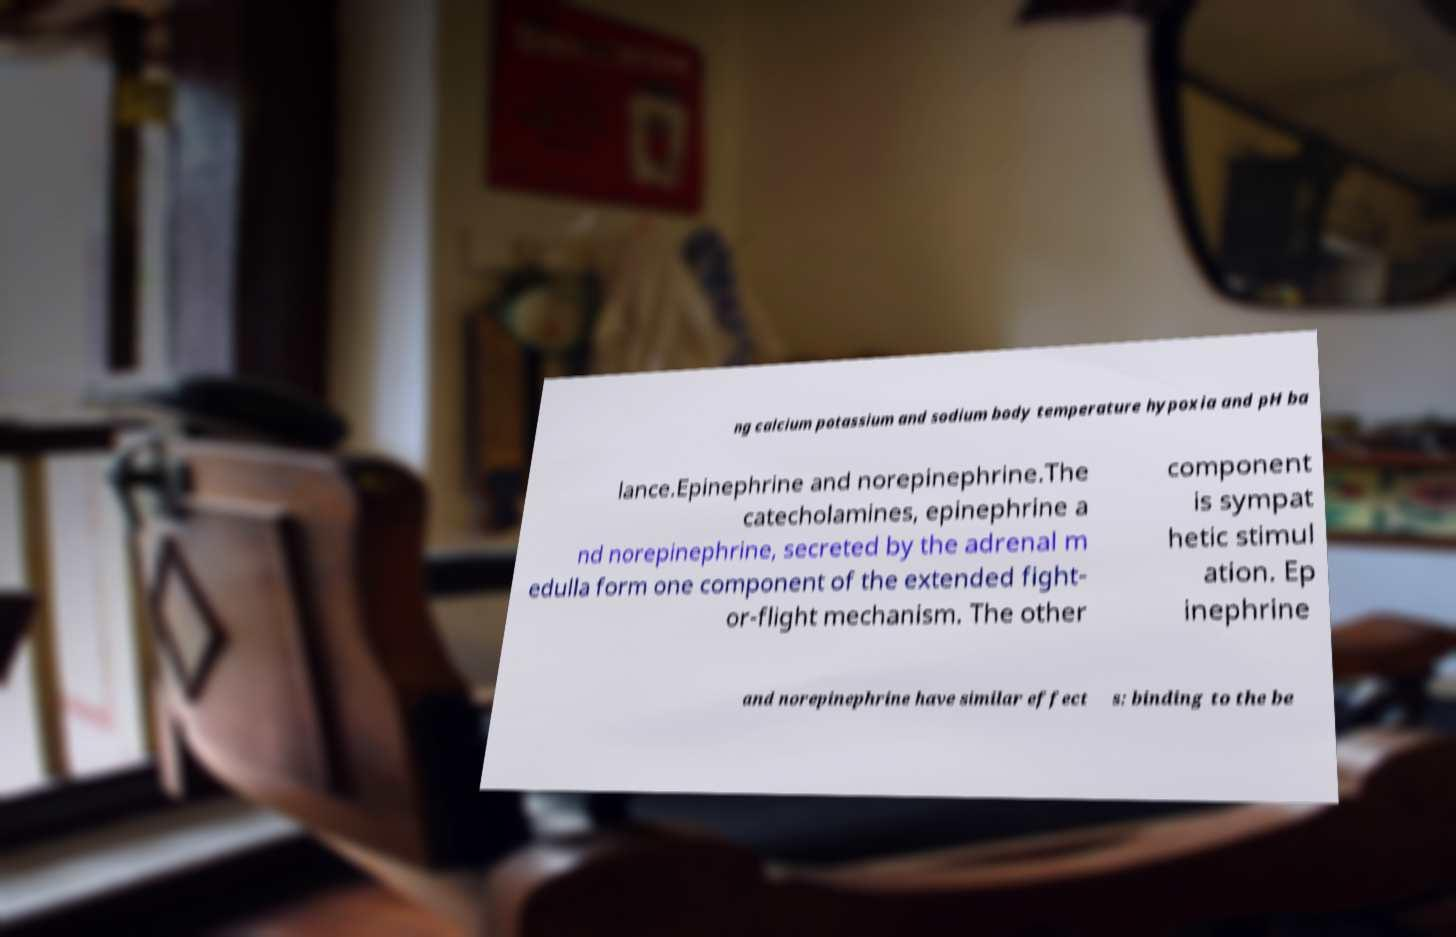I need the written content from this picture converted into text. Can you do that? ng calcium potassium and sodium body temperature hypoxia and pH ba lance.Epinephrine and norepinephrine.The catecholamines, epinephrine a nd norepinephrine, secreted by the adrenal m edulla form one component of the extended fight- or-flight mechanism. The other component is sympat hetic stimul ation. Ep inephrine and norepinephrine have similar effect s: binding to the be 